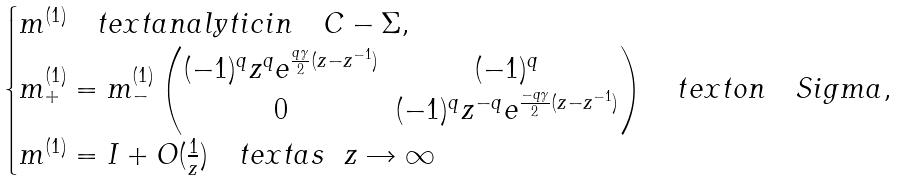<formula> <loc_0><loc_0><loc_500><loc_500>\begin{cases} m ^ { ( 1 ) } \quad t e x t { a n a l y t i c i n } \quad C - \Sigma , \\ m _ { + } ^ { ( 1 ) } = m _ { - } ^ { ( 1 ) } \begin{pmatrix} ( - 1 ) ^ { q } z ^ { q } e ^ { \frac { q \gamma } { 2 } ( z - z ^ { - 1 } ) } & ( - 1 ) ^ { q } \\ 0 & ( - 1 ) ^ { q } z ^ { - q } e ^ { \frac { - q \gamma } { 2 } ( z - z ^ { - 1 } ) } \end{pmatrix} \quad t e x t { o n } \ \ \ S i g m a , \\ m ^ { ( 1 ) } = I + O ( \frac { 1 } { z } ) \quad t e x t { a s } \ \ z \rightarrow \infty \\ \end{cases}</formula> 